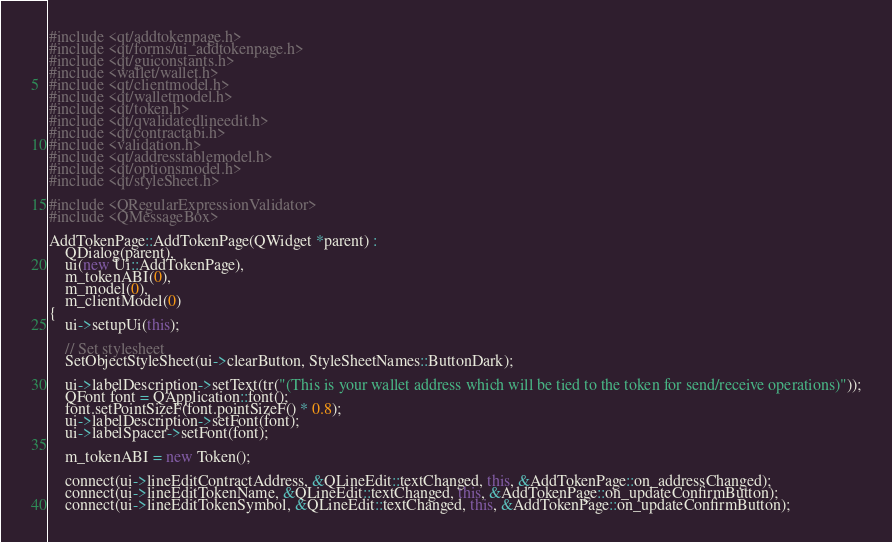<code> <loc_0><loc_0><loc_500><loc_500><_C++_>#include <qt/addtokenpage.h>
#include <qt/forms/ui_addtokenpage.h>
#include <qt/guiconstants.h>
#include <wallet/wallet.h>
#include <qt/clientmodel.h>
#include <qt/walletmodel.h>
#include <qt/token.h>
#include <qt/qvalidatedlineedit.h>
#include <qt/contractabi.h>
#include <validation.h>
#include <qt/addresstablemodel.h>
#include <qt/optionsmodel.h>
#include <qt/styleSheet.h>

#include <QRegularExpressionValidator>
#include <QMessageBox>

AddTokenPage::AddTokenPage(QWidget *parent) :
    QDialog(parent),
    ui(new Ui::AddTokenPage),
    m_tokenABI(0),
    m_model(0),
    m_clientModel(0)
{
    ui->setupUi(this);

    // Set stylesheet
    SetObjectStyleSheet(ui->clearButton, StyleSheetNames::ButtonDark);

    ui->labelDescription->setText(tr("(This is your wallet address which will be tied to the token for send/receive operations)"));
    QFont font = QApplication::font();
    font.setPointSizeF(font.pointSizeF() * 0.8);
    ui->labelDescription->setFont(font);
    ui->labelSpacer->setFont(font);

    m_tokenABI = new Token();

    connect(ui->lineEditContractAddress, &QLineEdit::textChanged, this, &AddTokenPage::on_addressChanged);
    connect(ui->lineEditTokenName, &QLineEdit::textChanged, this, &AddTokenPage::on_updateConfirmButton);
    connect(ui->lineEditTokenSymbol, &QLineEdit::textChanged, this, &AddTokenPage::on_updateConfirmButton);</code> 